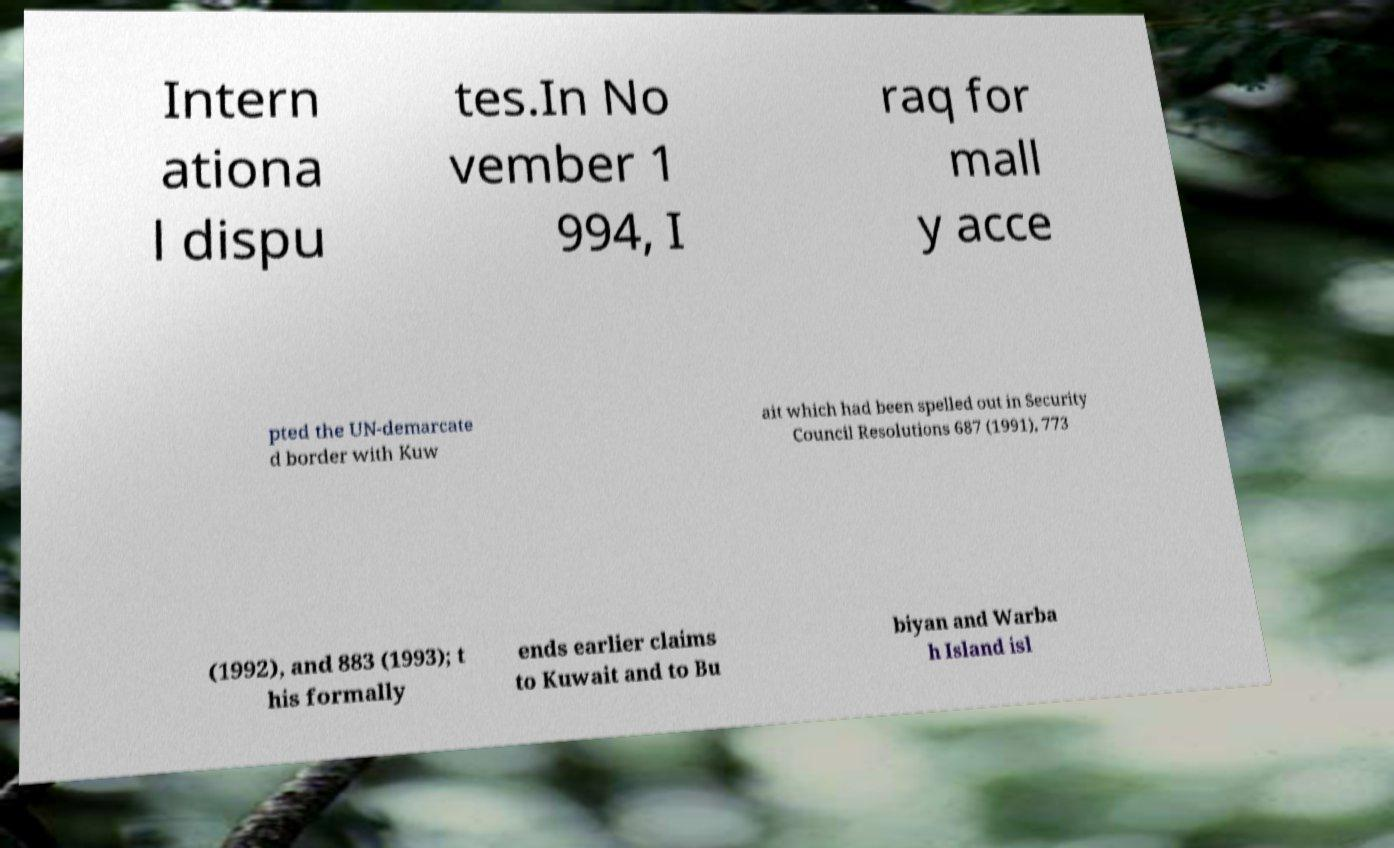Please read and relay the text visible in this image. What does it say? Intern ationa l dispu tes.In No vember 1 994, I raq for mall y acce pted the UN-demarcate d border with Kuw ait which had been spelled out in Security Council Resolutions 687 (1991), 773 (1992), and 883 (1993); t his formally ends earlier claims to Kuwait and to Bu biyan and Warba h Island isl 